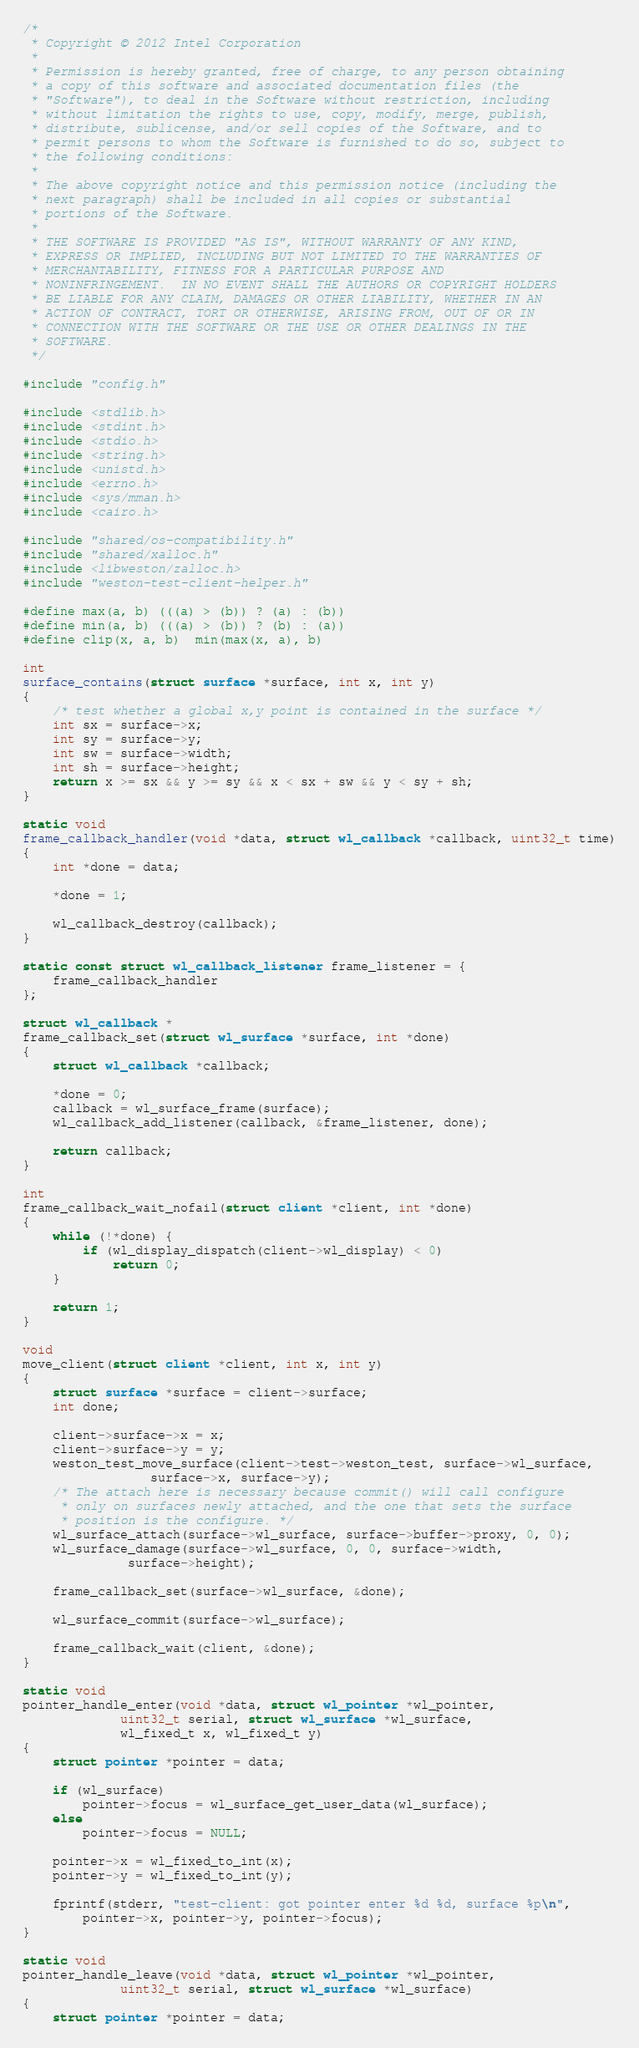<code> <loc_0><loc_0><loc_500><loc_500><_C_>/*
 * Copyright © 2012 Intel Corporation
 *
 * Permission is hereby granted, free of charge, to any person obtaining
 * a copy of this software and associated documentation files (the
 * "Software"), to deal in the Software without restriction, including
 * without limitation the rights to use, copy, modify, merge, publish,
 * distribute, sublicense, and/or sell copies of the Software, and to
 * permit persons to whom the Software is furnished to do so, subject to
 * the following conditions:
 *
 * The above copyright notice and this permission notice (including the
 * next paragraph) shall be included in all copies or substantial
 * portions of the Software.
 *
 * THE SOFTWARE IS PROVIDED "AS IS", WITHOUT WARRANTY OF ANY KIND,
 * EXPRESS OR IMPLIED, INCLUDING BUT NOT LIMITED TO THE WARRANTIES OF
 * MERCHANTABILITY, FITNESS FOR A PARTICULAR PURPOSE AND
 * NONINFRINGEMENT.  IN NO EVENT SHALL THE AUTHORS OR COPYRIGHT HOLDERS
 * BE LIABLE FOR ANY CLAIM, DAMAGES OR OTHER LIABILITY, WHETHER IN AN
 * ACTION OF CONTRACT, TORT OR OTHERWISE, ARISING FROM, OUT OF OR IN
 * CONNECTION WITH THE SOFTWARE OR THE USE OR OTHER DEALINGS IN THE
 * SOFTWARE.
 */

#include "config.h"

#include <stdlib.h>
#include <stdint.h>
#include <stdio.h>
#include <string.h>
#include <unistd.h>
#include <errno.h>
#include <sys/mman.h>
#include <cairo.h>

#include "shared/os-compatibility.h"
#include "shared/xalloc.h"
#include <libweston/zalloc.h>
#include "weston-test-client-helper.h"

#define max(a, b) (((a) > (b)) ? (a) : (b))
#define min(a, b) (((a) > (b)) ? (b) : (a))
#define clip(x, a, b)  min(max(x, a), b)

int
surface_contains(struct surface *surface, int x, int y)
{
	/* test whether a global x,y point is contained in the surface */
	int sx = surface->x;
	int sy = surface->y;
	int sw = surface->width;
	int sh = surface->height;
	return x >= sx && y >= sy && x < sx + sw && y < sy + sh;
}

static void
frame_callback_handler(void *data, struct wl_callback *callback, uint32_t time)
{
	int *done = data;

	*done = 1;

	wl_callback_destroy(callback);
}

static const struct wl_callback_listener frame_listener = {
	frame_callback_handler
};

struct wl_callback *
frame_callback_set(struct wl_surface *surface, int *done)
{
	struct wl_callback *callback;

	*done = 0;
	callback = wl_surface_frame(surface);
	wl_callback_add_listener(callback, &frame_listener, done);

	return callback;
}

int
frame_callback_wait_nofail(struct client *client, int *done)
{
	while (!*done) {
		if (wl_display_dispatch(client->wl_display) < 0)
			return 0;
	}

	return 1;
}

void
move_client(struct client *client, int x, int y)
{
	struct surface *surface = client->surface;
	int done;

	client->surface->x = x;
	client->surface->y = y;
	weston_test_move_surface(client->test->weston_test, surface->wl_surface,
			     surface->x, surface->y);
	/* The attach here is necessary because commit() will call configure
	 * only on surfaces newly attached, and the one that sets the surface
	 * position is the configure. */
	wl_surface_attach(surface->wl_surface, surface->buffer->proxy, 0, 0);
	wl_surface_damage(surface->wl_surface, 0, 0, surface->width,
			  surface->height);

	frame_callback_set(surface->wl_surface, &done);

	wl_surface_commit(surface->wl_surface);

	frame_callback_wait(client, &done);
}

static void
pointer_handle_enter(void *data, struct wl_pointer *wl_pointer,
		     uint32_t serial, struct wl_surface *wl_surface,
		     wl_fixed_t x, wl_fixed_t y)
{
	struct pointer *pointer = data;

	if (wl_surface)
		pointer->focus = wl_surface_get_user_data(wl_surface);
	else
		pointer->focus = NULL;

	pointer->x = wl_fixed_to_int(x);
	pointer->y = wl_fixed_to_int(y);

	fprintf(stderr, "test-client: got pointer enter %d %d, surface %p\n",
		pointer->x, pointer->y, pointer->focus);
}

static void
pointer_handle_leave(void *data, struct wl_pointer *wl_pointer,
		     uint32_t serial, struct wl_surface *wl_surface)
{
	struct pointer *pointer = data;
</code> 